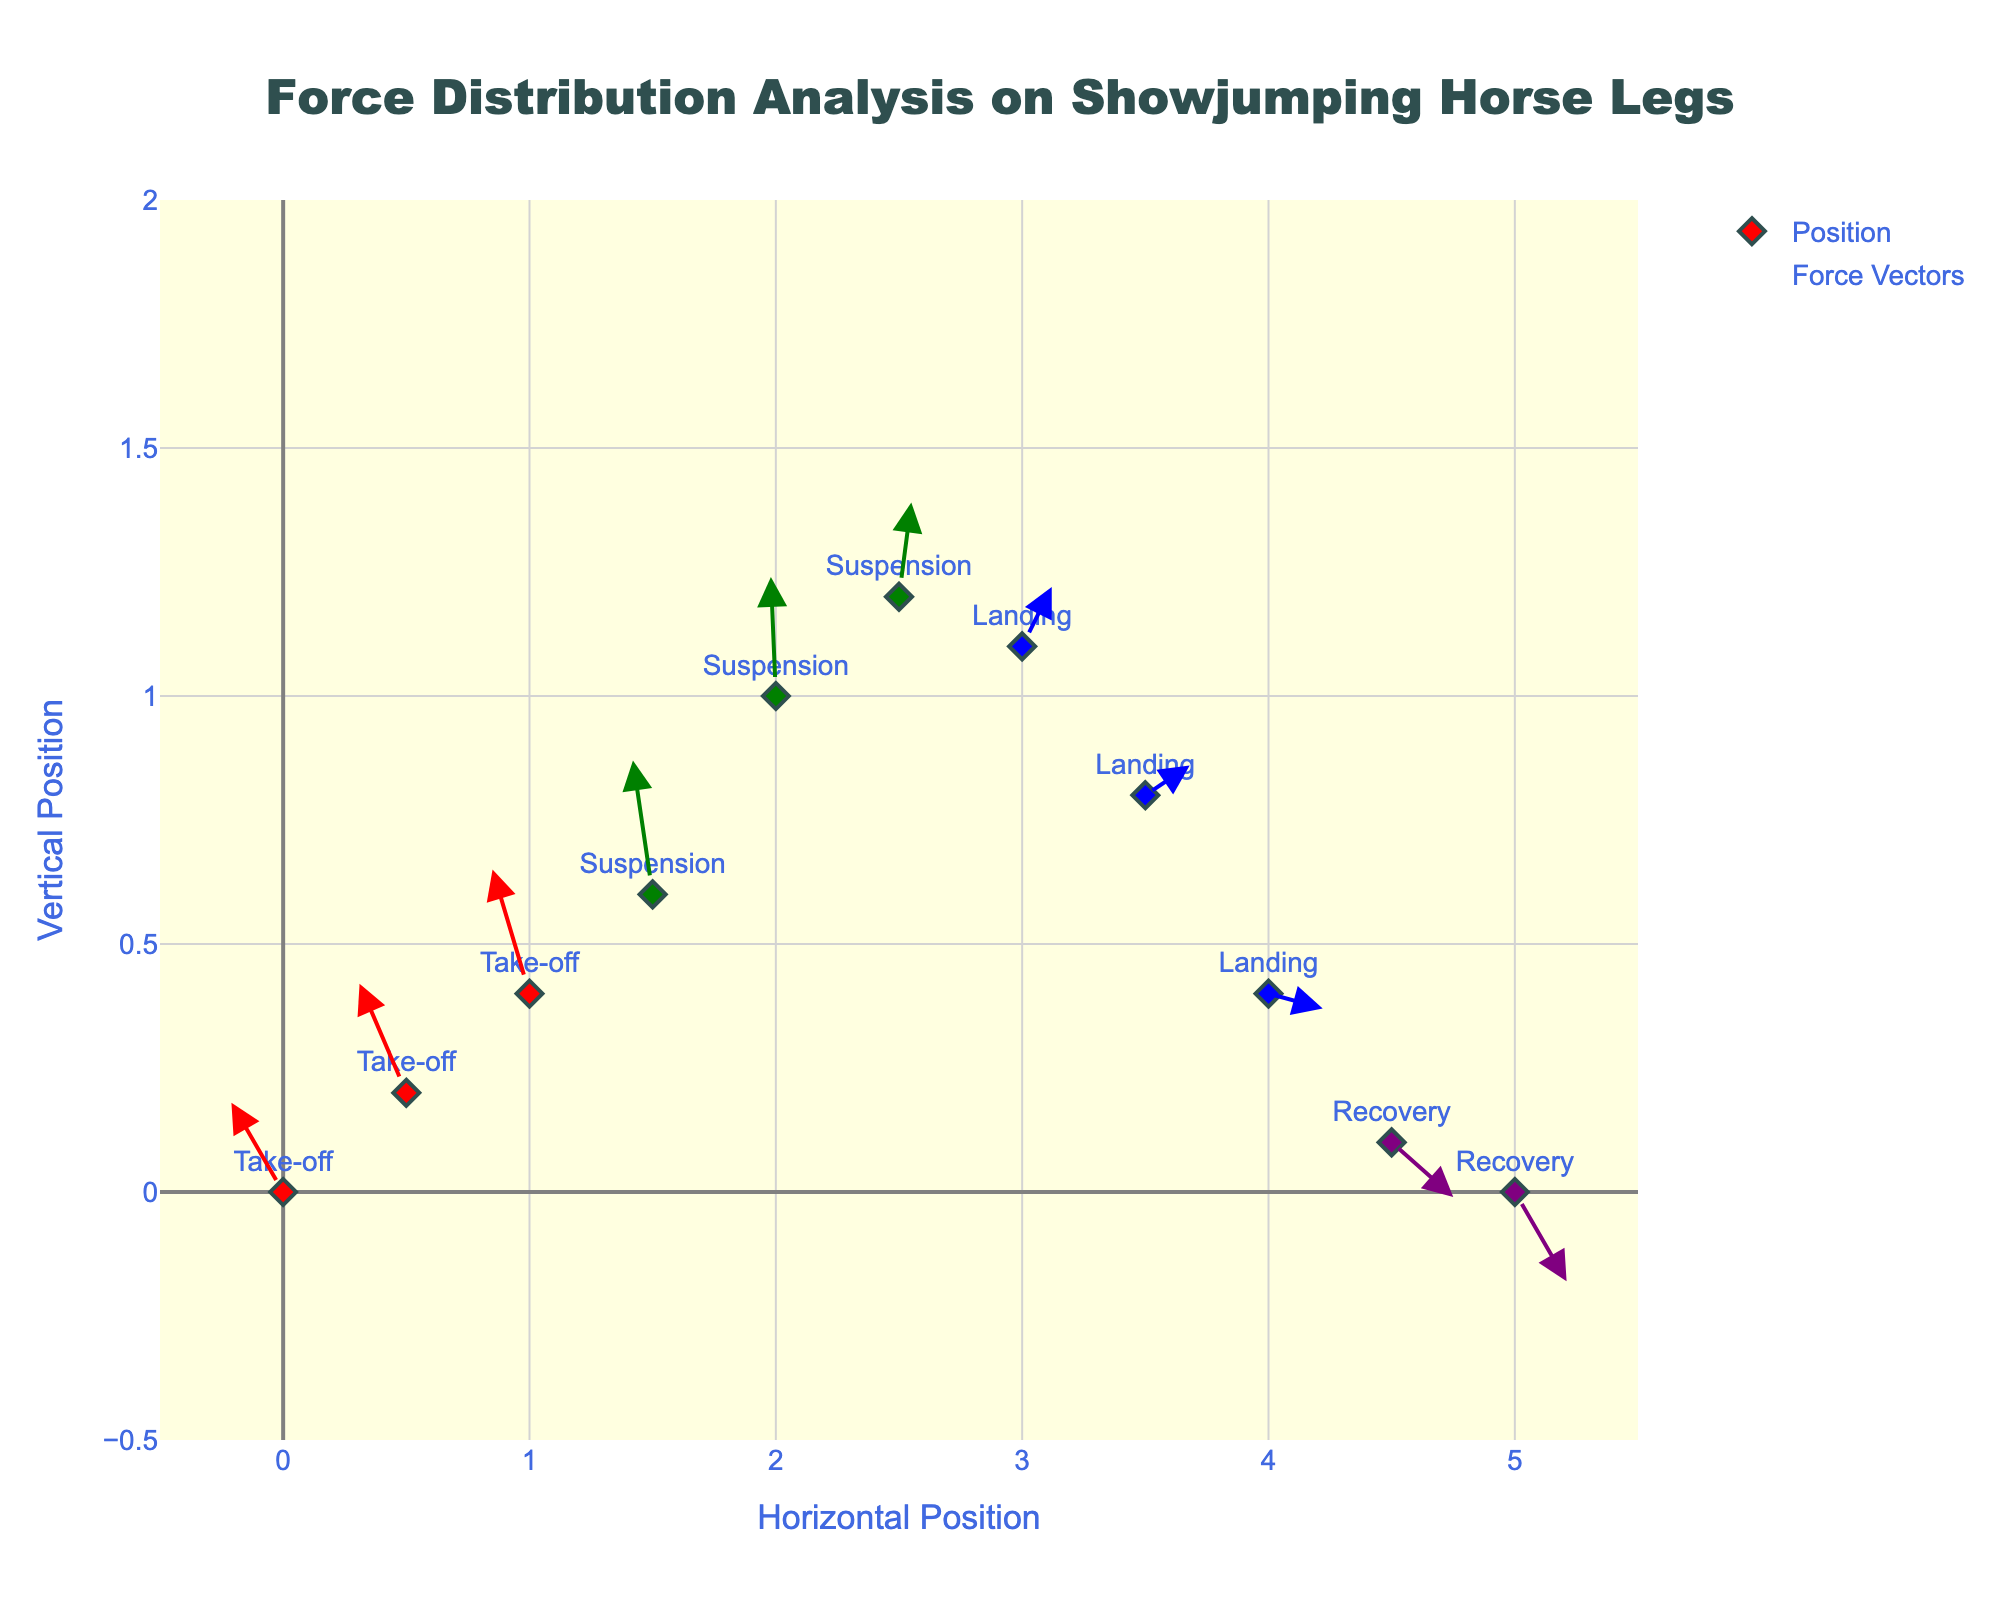How many phases are analyzed in the figure? By looking at the colors and labels of the different points, we see there are four phases: Take-off, Suspension, Landing, and Recovery.
Answer: Four Which phase has the highest vertical force component (v) at the beginning of the phase? If we look at the initial points of each phase, the vertical force components are: Take-off (1.8), Suspension (2.7), Landing (1.2), and Recovery (-1.1). The highest is during the Suspension phase with a value of 2.7.
Answer: Suspension Compare the horizontal force (u) for the Take-off phase with the Recovery phase. Which phase shows a trend of increasing horizontal force? By looking at the arrows' lengths and directions during each phase: for Take-off, the horizontal components are -2.1, -1.9, and -1.5; while in Recovery, they are 2.5 and 2.1, showing an increasing trend in Recovery.
Answer: Recovery What is the combined vertical force (v) at x=4.5 in the Landing and Recovery phases? At x=4.5, in the Landing phase, there is no data point, but in the Recovery phase, the vertical force (v) is -1.1. So, the combined value is -1.1.
Answer: -1.1 Identify the phase where horizontal force (u) becomes positive. Observing the arrows, the phase where horizontal force changes from negative to positive happens during the Suspension phase (starting from 2.5,1.2).
Answer: Suspension Does the force direction change significantly during the Landing phase? By analyzing the arrows in the Landing phase, the direction goes from upwards to downwards, indicating a significant change in force direction.
Answer: Yes Which phase has the smallest horizontal force component (u)? Checking the smallest magnitude values for horizontal forces shows that during the Suspension phase, there is a value of -0.2, the smallest across all phases.
Answer: Suspension What is the direction of the force vector at point (1, 0.4) in the Take-off phase? At point (1,0.4) in the Take-off phase, the direction is given by the vector (-1.5,2.5). This generally shows a direction upwards and to the left.
Answer: Upwards and left How do the magnitudes of force components (u, v) compare at the end of the Take-off and the beginning of the Suspension phase? The ending values during Take-off (1.5,0.6) are (-0.8, 2.7) and the beginning of Suspension (2,1) are (-0.2, 2.4). Magnitude-wise: Take-off has sqrt((-0.8)^2 + 2.7^2) and Suspension has sqrt((-0.2)^2 + 2.4^2); Take-off has a larger force magnitude.
Answer: Take-off Which phase demonstrates the highest change in vertical position (y) between its start and end point? By examining the y-positions for each phase: Take-off (0 to 0.6), Suspension (0.6 to 1.2), Landing (1.2 to 0.4), Recovery (0.4 to 0). The highest change is for Suspension with a difference of 0.6.
Answer: Suspension 